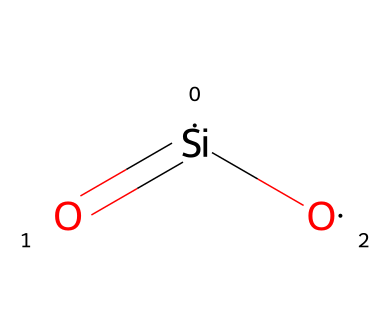What is the central atom in this chemical? The central atom in the structure is silicon, as indicated by the notation [Si] in the SMILES representation.
Answer: silicon How many oxygen atoms are present in silicon dioxide? The structure contains two oxygen atoms, represented by two [O] symbols connected to the silicon atom.
Answer: two What type of bonds are present between silicon and oxygen? The structure exhibits a double bond between the silicon atom and one oxygen atom and a single bond with another oxygen atom. The double bond is denoted by the "=" symbol in the SMILES.
Answer: double bond and single bond What is the total number of covalent bonds in silicon dioxide? There are a total of three covalent bonds in the structure: one double bond and one single bond to the oxygen atoms. This totals three individual bonds.
Answer: three What is the molecular geometry of silicon dioxide? The geometry around the silicon atom in silicon dioxide is tetrahedral, resulting from the two bonding pairs and the two lone pairs of electrons, influenced by the presence of two oxygen atoms.
Answer: tetrahedral What kind of compound is silicon dioxide categorized as? Silicon dioxide is categorized as an inorganic compound, as it is composed of silicon and oxygen, which are non-metals often found in minerals and glassware.
Answer: inorganic compound 